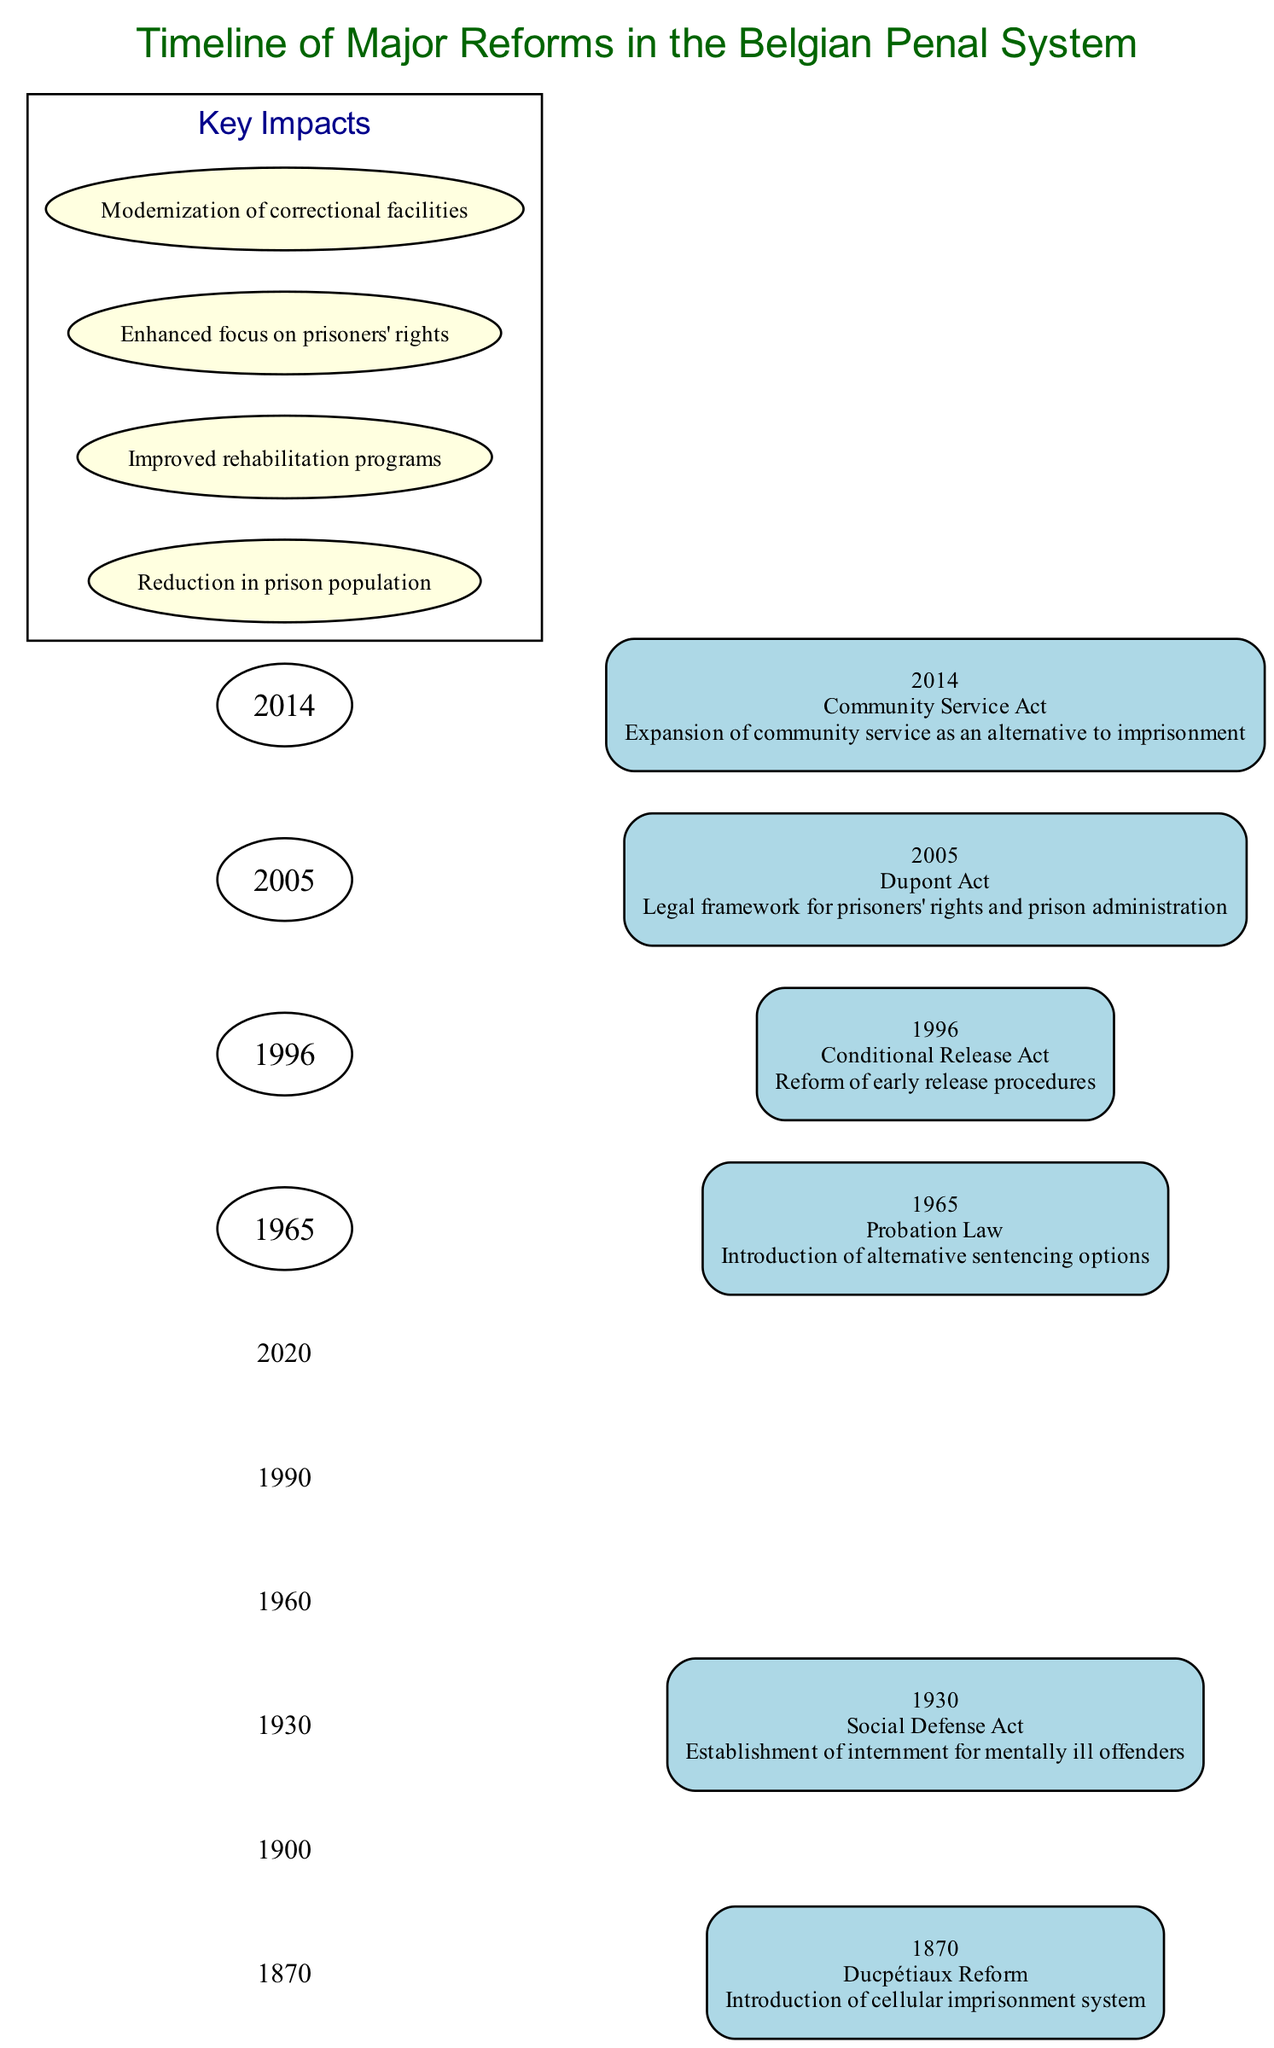What year did the Ducpétiaux Reform occur? The Ducpétiaux Reform is listed as the first event on the timeline, and it occurred in the year 1870 as indicated by the corresponding node on the timeline.
Answer: 1870 What is the main impact of the 2005 Dupont Act? The Dupont Act, which took place in 2005, introduced a legal framework for prisoners' rights and prison administration, as stated in the diagram next to this event.
Answer: Legal framework for prisoners' rights and prison administration How many major reforms are depicted in the timeline? By counting the number of events listed in the timeline, there are six major reforms presented: Ducpétiaux Reform, Social Defense Act, Probation Law, Conditional Release Act, Dupont Act, and Community Service Act.
Answer: 6 Which reform focused on mentally ill offenders? The Social Defense Act, which occurred in 1930, specifically addressed the establishment of internment for mentally ill offenders according to the text provided in the timeline.
Answer: Social Defense Act What impact is associated with the introduction of the Probation Law? The introduction of the Probation Law in 1965 led to the provision of alternative sentencing options, as described in the impact noted next to that event on the diagram.
Answer: Introduction of alternative sentencing options What is a key impact listed for the reforms depicted in the diagram? The diagram lists multiple key impacts, one of which is the "Improved rehabilitation programs," highlighting the improvements made in rehabilitation due to the reforms.
Answer: Improved rehabilitation programs Which year saw significant reforms affecting the release procedures of prisoners? The diagram shows that the Conditional Release Act, which reformed early release procedures, was enacted in 1996, indicating that this year was significant for changes in release procedures.
Answer: 1996 What is the general trend of impacts highlighted in the timeline? The timeline illustrates a trend towards modernization and improvement in correctional facilities, specifically mentioning aspects such as reduced prison population, improved rehabilitation programs, and enhanced focus on prisoners' rights as key impacts.
Answer: Modernization of correctional facilities 